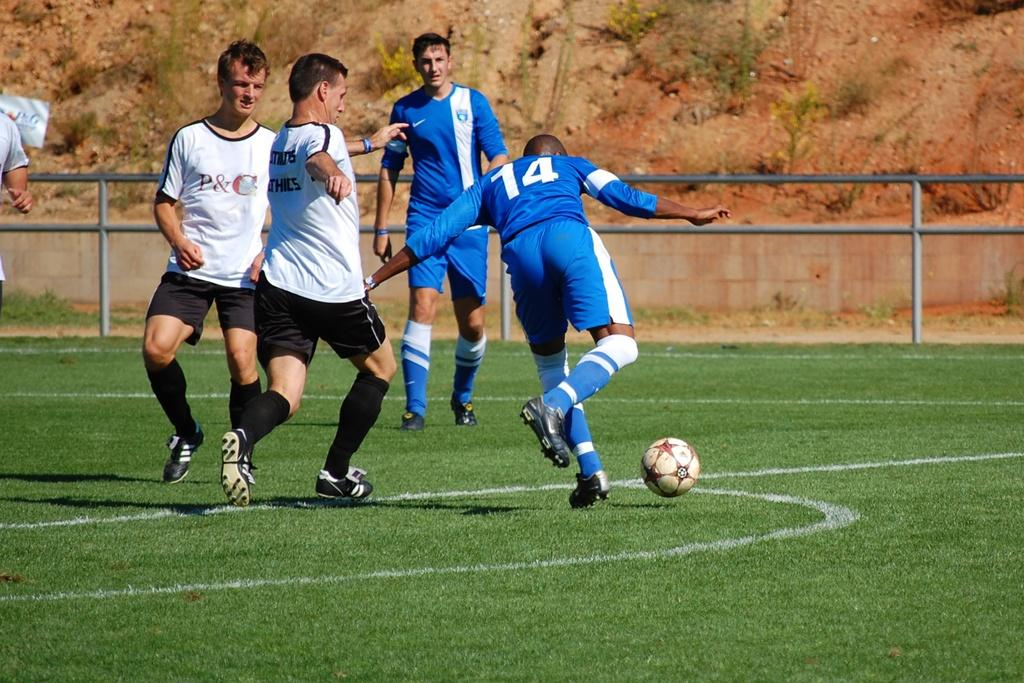<image>
Create a compact narrative representing the image presented. A soccer game is underway and the player kicking the ball has a 14 on his uniform. 